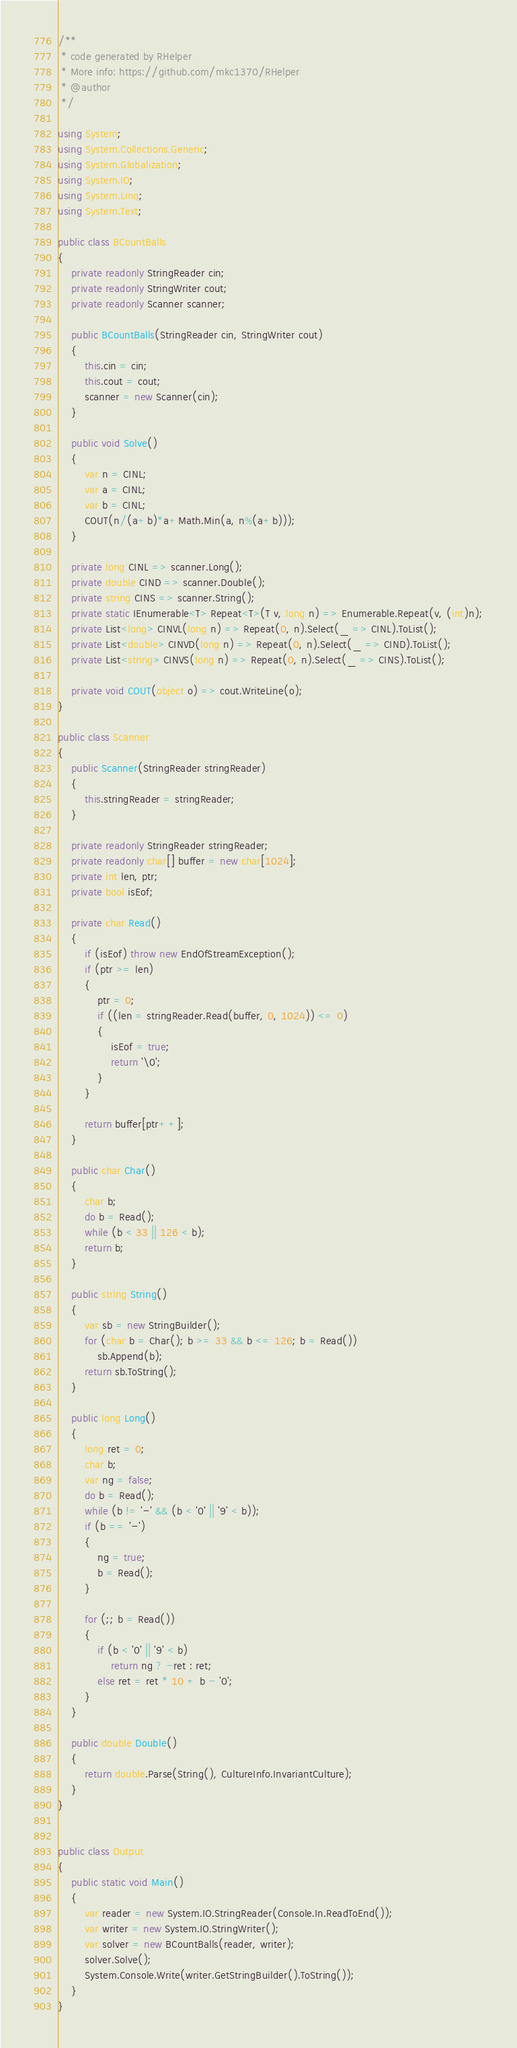Convert code to text. <code><loc_0><loc_0><loc_500><loc_500><_C#_>/**
 * code generated by RHelper
 * More info: https://github.com/mkc1370/RHelper
 * @author 
 */

using System;
using System.Collections.Generic;
using System.Globalization;
using System.IO;
using System.Linq;
using System.Text;

public class BCountBalls
{
    private readonly StringReader cin;
    private readonly StringWriter cout;
    private readonly Scanner scanner;

    public BCountBalls(StringReader cin, StringWriter cout)
    {
        this.cin = cin;
        this.cout = cout;
        scanner = new Scanner(cin);
    }

    public void Solve()
    {
        var n = CINL;
        var a = CINL;
        var b = CINL;
        COUT(n/(a+b)*a+Math.Min(a, n%(a+b)));
    }

    private long CINL => scanner.Long();
    private double CIND => scanner.Double();
    private string CINS => scanner.String();
    private static IEnumerable<T> Repeat<T>(T v, long n) => Enumerable.Repeat(v, (int)n);
    private List<long> CINVL(long n) => Repeat(0, n).Select(_ => CINL).ToList();
    private List<double> CINVD(long n) => Repeat(0, n).Select(_ => CIND).ToList();
    private List<string> CINVS(long n) => Repeat(0, n).Select(_ => CINS).ToList();

    private void COUT(object o) => cout.WriteLine(o);
}

public class Scanner
{
    public Scanner(StringReader stringReader)
    {
        this.stringReader = stringReader;
    }

    private readonly StringReader stringReader;
    private readonly char[] buffer = new char[1024];
    private int len, ptr;
    private bool isEof;

    private char Read()
    {
        if (isEof) throw new EndOfStreamException();
        if (ptr >= len)
        {
            ptr = 0;
            if ((len = stringReader.Read(buffer, 0, 1024)) <= 0)
            {
                isEof = true;
                return '\0';
            }
        }

        return buffer[ptr++];
    }

    public char Char()
    {
        char b;
        do b = Read();
        while (b < 33 || 126 < b);
        return b;
    }

    public string String()
    {
        var sb = new StringBuilder();
        for (char b = Char(); b >= 33 && b <= 126; b = Read())
            sb.Append(b);
        return sb.ToString();
    }

    public long Long()
    {
        long ret = 0;
        char b;
        var ng = false;
        do b = Read();
        while (b != '-' && (b < '0' || '9' < b));
        if (b == '-')
        {
            ng = true;
            b = Read();
        }

        for (;; b = Read())
        {
            if (b < '0' || '9' < b)
                return ng ? -ret : ret;
            else ret = ret * 10 + b - '0';
        }
    }

    public double Double()
    {
        return double.Parse(String(), CultureInfo.InvariantCulture);
    }
}


public class Output
{
	public static void Main()
	{
		var reader = new System.IO.StringReader(Console.In.ReadToEnd());
		var writer = new System.IO.StringWriter();
		var solver = new BCountBalls(reader, writer);
		solver.Solve();
		System.Console.Write(writer.GetStringBuilder().ToString());
	}
}
</code> 